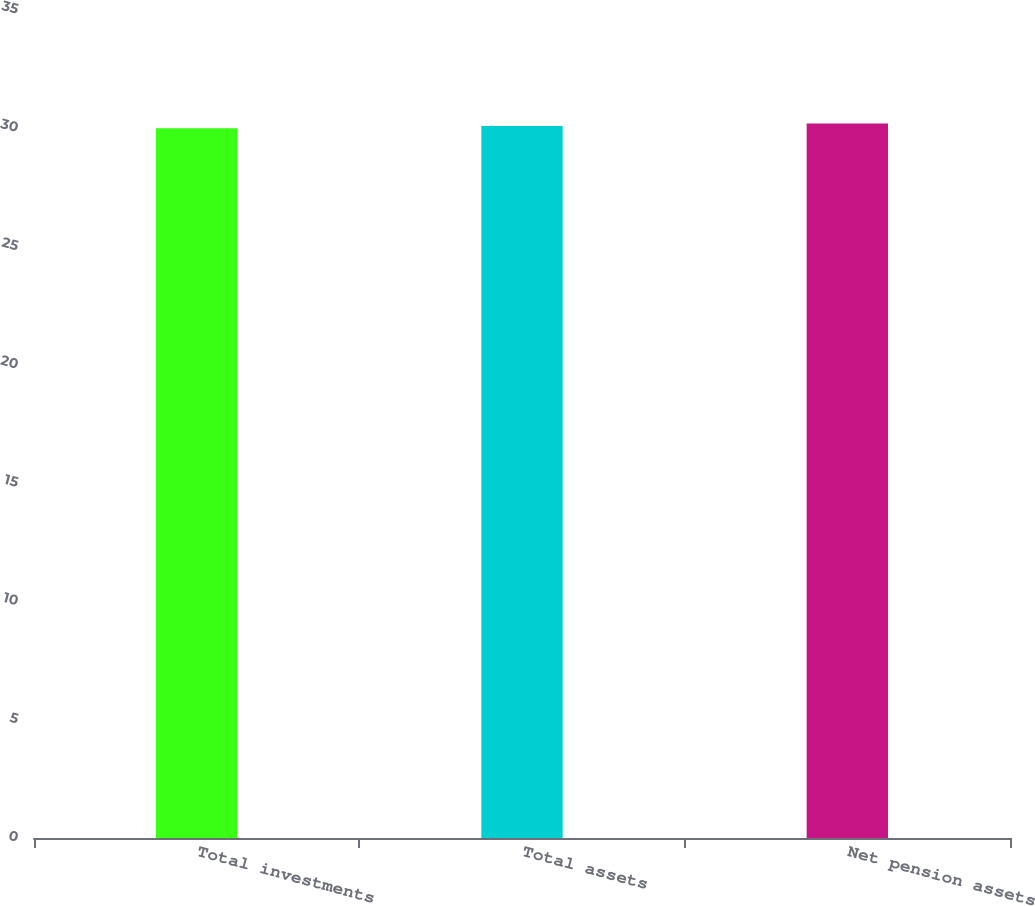Convert chart to OTSL. <chart><loc_0><loc_0><loc_500><loc_500><bar_chart><fcel>Total investments<fcel>Total assets<fcel>Net pension assets<nl><fcel>30<fcel>30.1<fcel>30.2<nl></chart> 